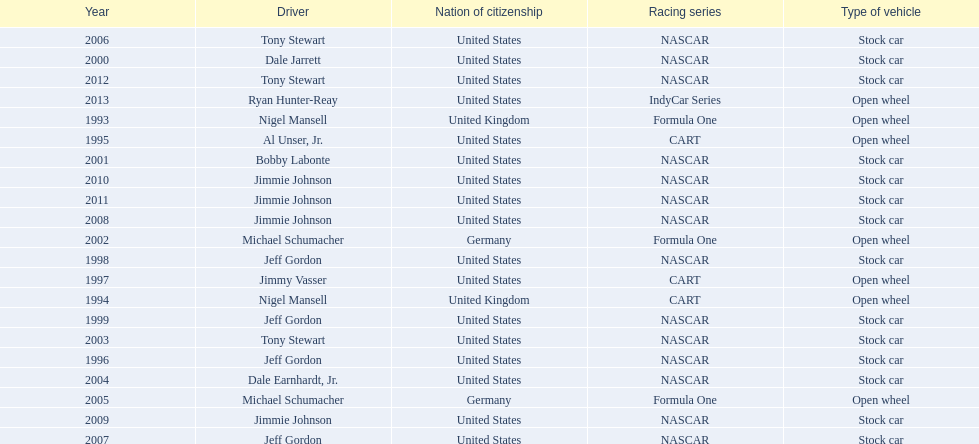Which drivers have won the best driver espy award? Nigel Mansell, Nigel Mansell, Al Unser, Jr., Jeff Gordon, Jimmy Vasser, Jeff Gordon, Jeff Gordon, Dale Jarrett, Bobby Labonte, Michael Schumacher, Tony Stewart, Dale Earnhardt, Jr., Michael Schumacher, Tony Stewart, Jeff Gordon, Jimmie Johnson, Jimmie Johnson, Jimmie Johnson, Jimmie Johnson, Tony Stewart, Ryan Hunter-Reay. Of these, which only appear once? Al Unser, Jr., Jimmy Vasser, Dale Jarrett, Dale Earnhardt, Jr., Ryan Hunter-Reay. Which of these are from the cart racing series? Al Unser, Jr., Jimmy Vasser. Of these, which received their award first? Al Unser, Jr. 